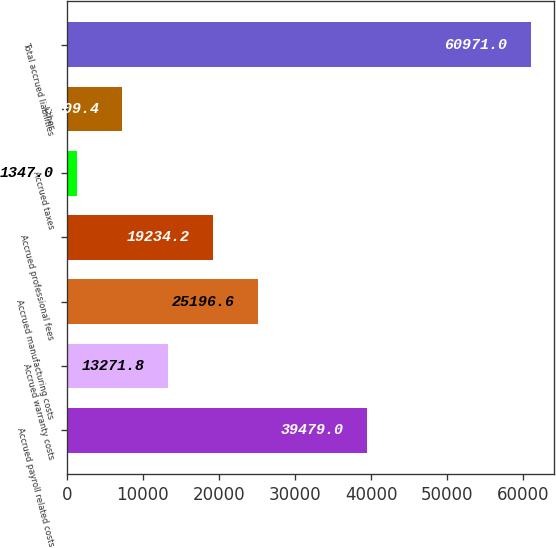Convert chart. <chart><loc_0><loc_0><loc_500><loc_500><bar_chart><fcel>Accrued payroll related costs<fcel>Accrued warranty costs<fcel>Accrued manufacturing costs<fcel>Accrued professional fees<fcel>Accrued taxes<fcel>Other<fcel>Total accrued liabilities<nl><fcel>39479<fcel>13271.8<fcel>25196.6<fcel>19234.2<fcel>1347<fcel>7309.4<fcel>60971<nl></chart> 